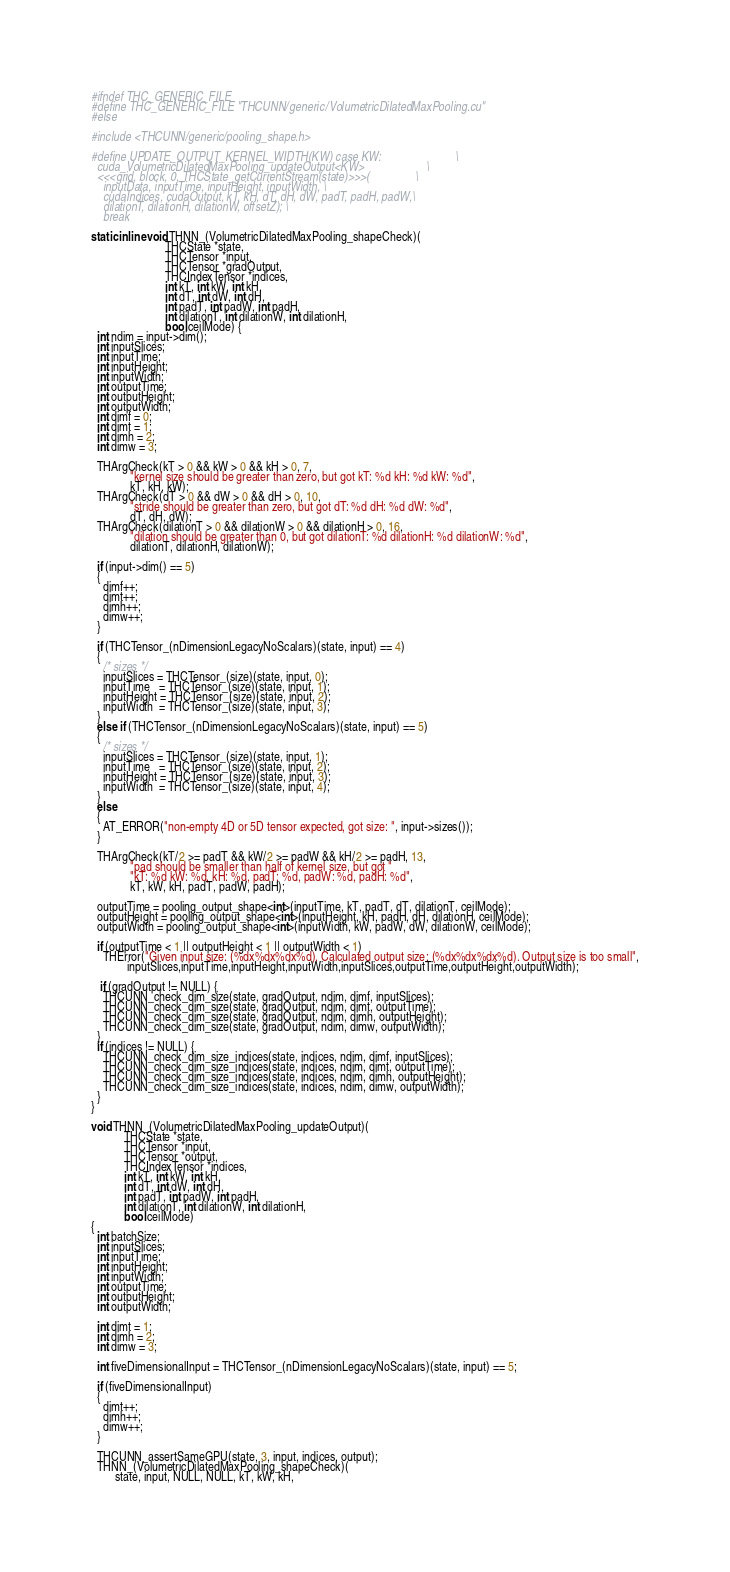Convert code to text. <code><loc_0><loc_0><loc_500><loc_500><_Cuda_>#ifndef THC_GENERIC_FILE
#define THC_GENERIC_FILE "THCUNN/generic/VolumetricDilatedMaxPooling.cu"
#else

#include <THCUNN/generic/pooling_shape.h>

#define UPDATE_OUTPUT_KERNEL_WIDTH(KW) case KW:                         \
  cuda_VolumetricDilatedMaxPooling_updateOutput<KW>                     \
  <<<grid, block, 0, THCState_getCurrentStream(state)>>>(               \
    inputData, inputTime, inputHeight, inputWidth, \
    cudaIndices, cudaOutput, kT, kH, dT, dH, dW, padT, padH, padW,\
    dilationT, dilationH, dilationW, offsetZ); \
    break

static inline void THNN_(VolumetricDilatedMaxPooling_shapeCheck)(
                         THCState *state,
                         THCTensor *input,
                         THCTensor *gradOutput,
                         THCIndexTensor *indices,
                         int kT, int kW, int kH,
                         int dT, int dW, int dH,
                         int padT, int padW, int padH,
                         int dilationT, int dilationW, int dilationH,
                         bool ceilMode) {
  int ndim = input->dim();
  int inputSlices;
  int inputTime;
  int inputHeight;
  int inputWidth;
  int outputTime;
  int outputHeight;
  int outputWidth;
  int dimf = 0;
  int dimt = 1;
  int dimh = 2;
  int dimw = 3;

  THArgCheck(kT > 0 && kW > 0 && kH > 0, 7,
             "kernel size should be greater than zero, but got kT: %d kH: %d kW: %d",
             kT, kH, kW);
  THArgCheck(dT > 0 && dW > 0 && dH > 0, 10,
             "stride should be greater than zero, but got dT: %d dH: %d dW: %d",
             dT, dH, dW);
  THArgCheck(dilationT > 0 && dilationW > 0 && dilationH > 0, 16,
             "dilation should be greater than 0, but got dilationT: %d dilationH: %d dilationW: %d",
             dilationT, dilationH, dilationW);

  if (input->dim() == 5)
  {
    dimf++;
    dimt++;
    dimh++;
    dimw++;
  }

  if (THCTensor_(nDimensionLegacyNoScalars)(state, input) == 4)
  {
    /* sizes */
    inputSlices = THCTensor_(size)(state, input, 0);
    inputTime   = THCTensor_(size)(state, input, 1);
    inputHeight = THCTensor_(size)(state, input, 2);
    inputWidth  = THCTensor_(size)(state, input, 3);
  }
  else if (THCTensor_(nDimensionLegacyNoScalars)(state, input) == 5)
  {
    /* sizes */
    inputSlices = THCTensor_(size)(state, input, 1);
    inputTime   = THCTensor_(size)(state, input, 2);
    inputHeight = THCTensor_(size)(state, input, 3);
    inputWidth  = THCTensor_(size)(state, input, 4);
  }
  else
  {
    AT_ERROR("non-empty 4D or 5D tensor expected, got size: ", input->sizes());
  }

  THArgCheck(kT/2 >= padT && kW/2 >= padW && kH/2 >= padH, 13,
             "pad should be smaller than half of kernel size, but got "
             "kT: %d kW: %d, kH: %d, padT: %d, padW: %d, padH: %d",
             kT, kW, kH, padT, padW, padH);

  outputTime = pooling_output_shape<int>(inputTime, kT, padT, dT, dilationT, ceilMode);
  outputHeight = pooling_output_shape<int>(inputHeight, kH, padH, dH, dilationH, ceilMode);
  outputWidth = pooling_output_shape<int>(inputWidth, kW, padW, dW, dilationW, ceilMode);

  if (outputTime < 1 || outputHeight < 1 || outputWidth < 1)
    THError("Given input size: (%dx%dx%dx%d). Calculated output size: (%dx%dx%dx%d). Output size is too small",
            inputSlices,inputTime,inputHeight,inputWidth,inputSlices,outputTime,outputHeight,outputWidth);

   if (gradOutput != NULL) {
    THCUNN_check_dim_size(state, gradOutput, ndim, dimf, inputSlices);
    THCUNN_check_dim_size(state, gradOutput, ndim, dimt, outputTime);
    THCUNN_check_dim_size(state, gradOutput, ndim, dimh, outputHeight);
    THCUNN_check_dim_size(state, gradOutput, ndim, dimw, outputWidth);
  }
  if (indices != NULL) {
    THCUNN_check_dim_size_indices(state, indices, ndim, dimf, inputSlices);
    THCUNN_check_dim_size_indices(state, indices, ndim, dimt, outputTime);
    THCUNN_check_dim_size_indices(state, indices, ndim, dimh, outputHeight);
    THCUNN_check_dim_size_indices(state, indices, ndim, dimw, outputWidth);
  }
}

void THNN_(VolumetricDilatedMaxPooling_updateOutput)(
           THCState *state,
           THCTensor *input,
           THCTensor *output,
           THCIndexTensor *indices,
           int kT, int kW, int kH,
           int dT, int dW, int dH,
           int padT, int padW, int padH,
           int dilationT, int dilationW, int dilationH,
           bool ceilMode)
{
  int batchSize;
  int inputSlices;
  int inputTime;
  int inputHeight;
  int inputWidth;
  int outputTime;
  int outputHeight;
  int outputWidth;

  int dimt = 1;
  int dimh = 2;
  int dimw = 3;

  int fiveDimensionalInput = THCTensor_(nDimensionLegacyNoScalars)(state, input) == 5;

  if (fiveDimensionalInput)
  {
    dimt++;
    dimh++;
    dimw++;
  }

  THCUNN_assertSameGPU(state, 3, input, indices, output);
  THNN_(VolumetricDilatedMaxPooling_shapeCheck)(
        state, input, NULL, NULL, kT, kW, kH,</code> 